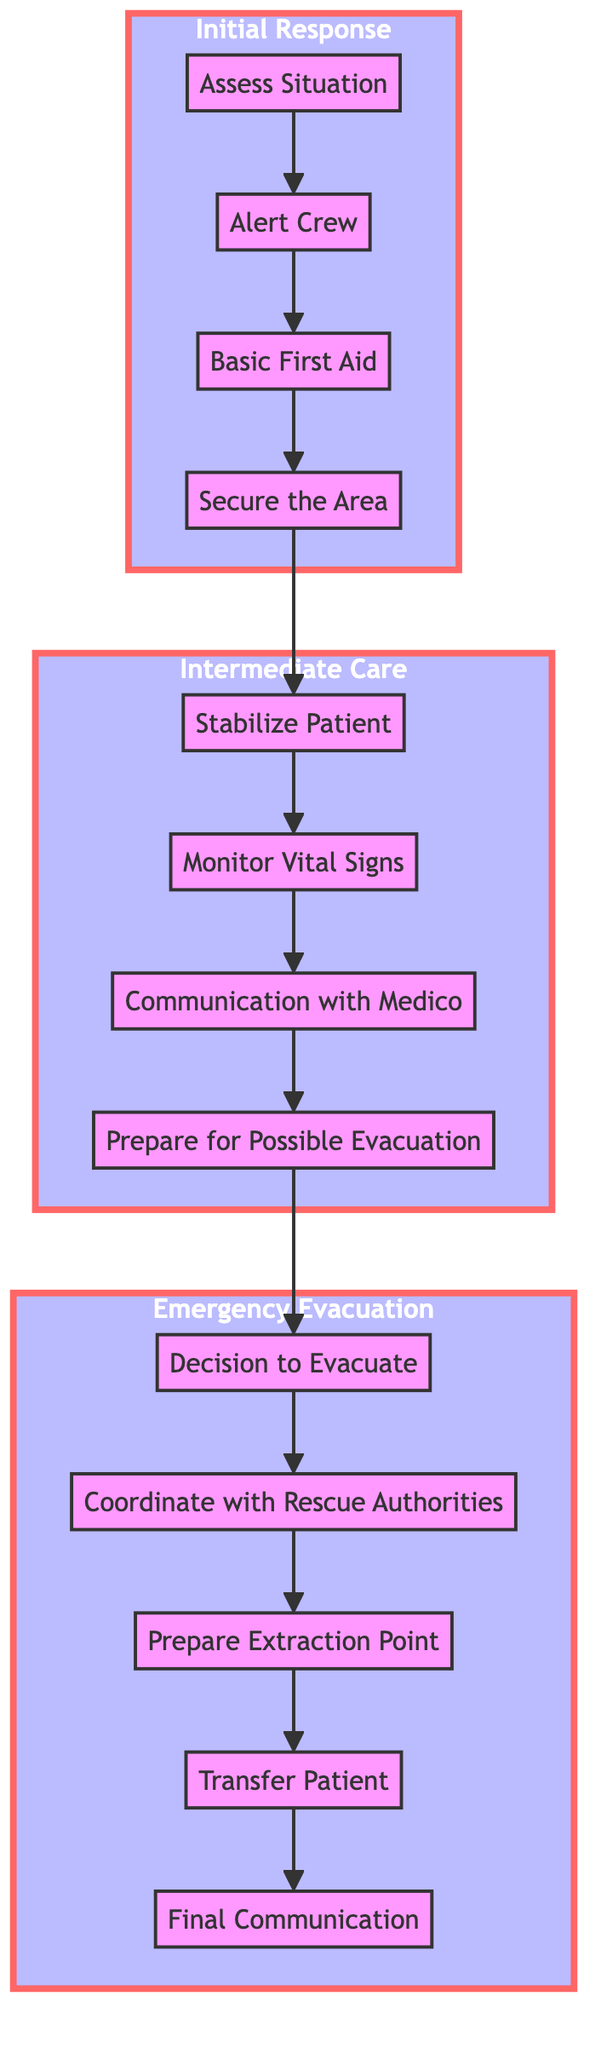What is the first step in the Initial Response? The first step in the Initial Response is "Assess Situation," where one evaluates the scene for safety and identifies the injured or ill crew member.
Answer: Assess Situation How many steps are in the Intermediate Care category? The Intermediate Care category contains four steps: Stabilize Patient, Monitor Vital Signs, Communication with Medico, and Prepare for Possible Evacuation.
Answer: Four What is the last step in the Emergency Evacuation process? The last step in the Emergency Evacuation is "Final Communication," which involves maintaining communication with the rescue team until the patient is safely evacuated.
Answer: Final Communication Which step follows "Secure the Area"? After "Secure the Area," the next step is "Stabilize Patient," indicating that securing the area leads directly into providing care for the injured individual.
Answer: Stabilize Patient What two categories are connected by the step "Prepare for Possible Evacuation"? The step "Prepare for Possible Evacuation" connects the Intermediate Care category and the Emergency Evacuation category, as it indicates preparation for moving to evacuation if necessary.
Answer: Intermediate Care and Emergency Evacuation 